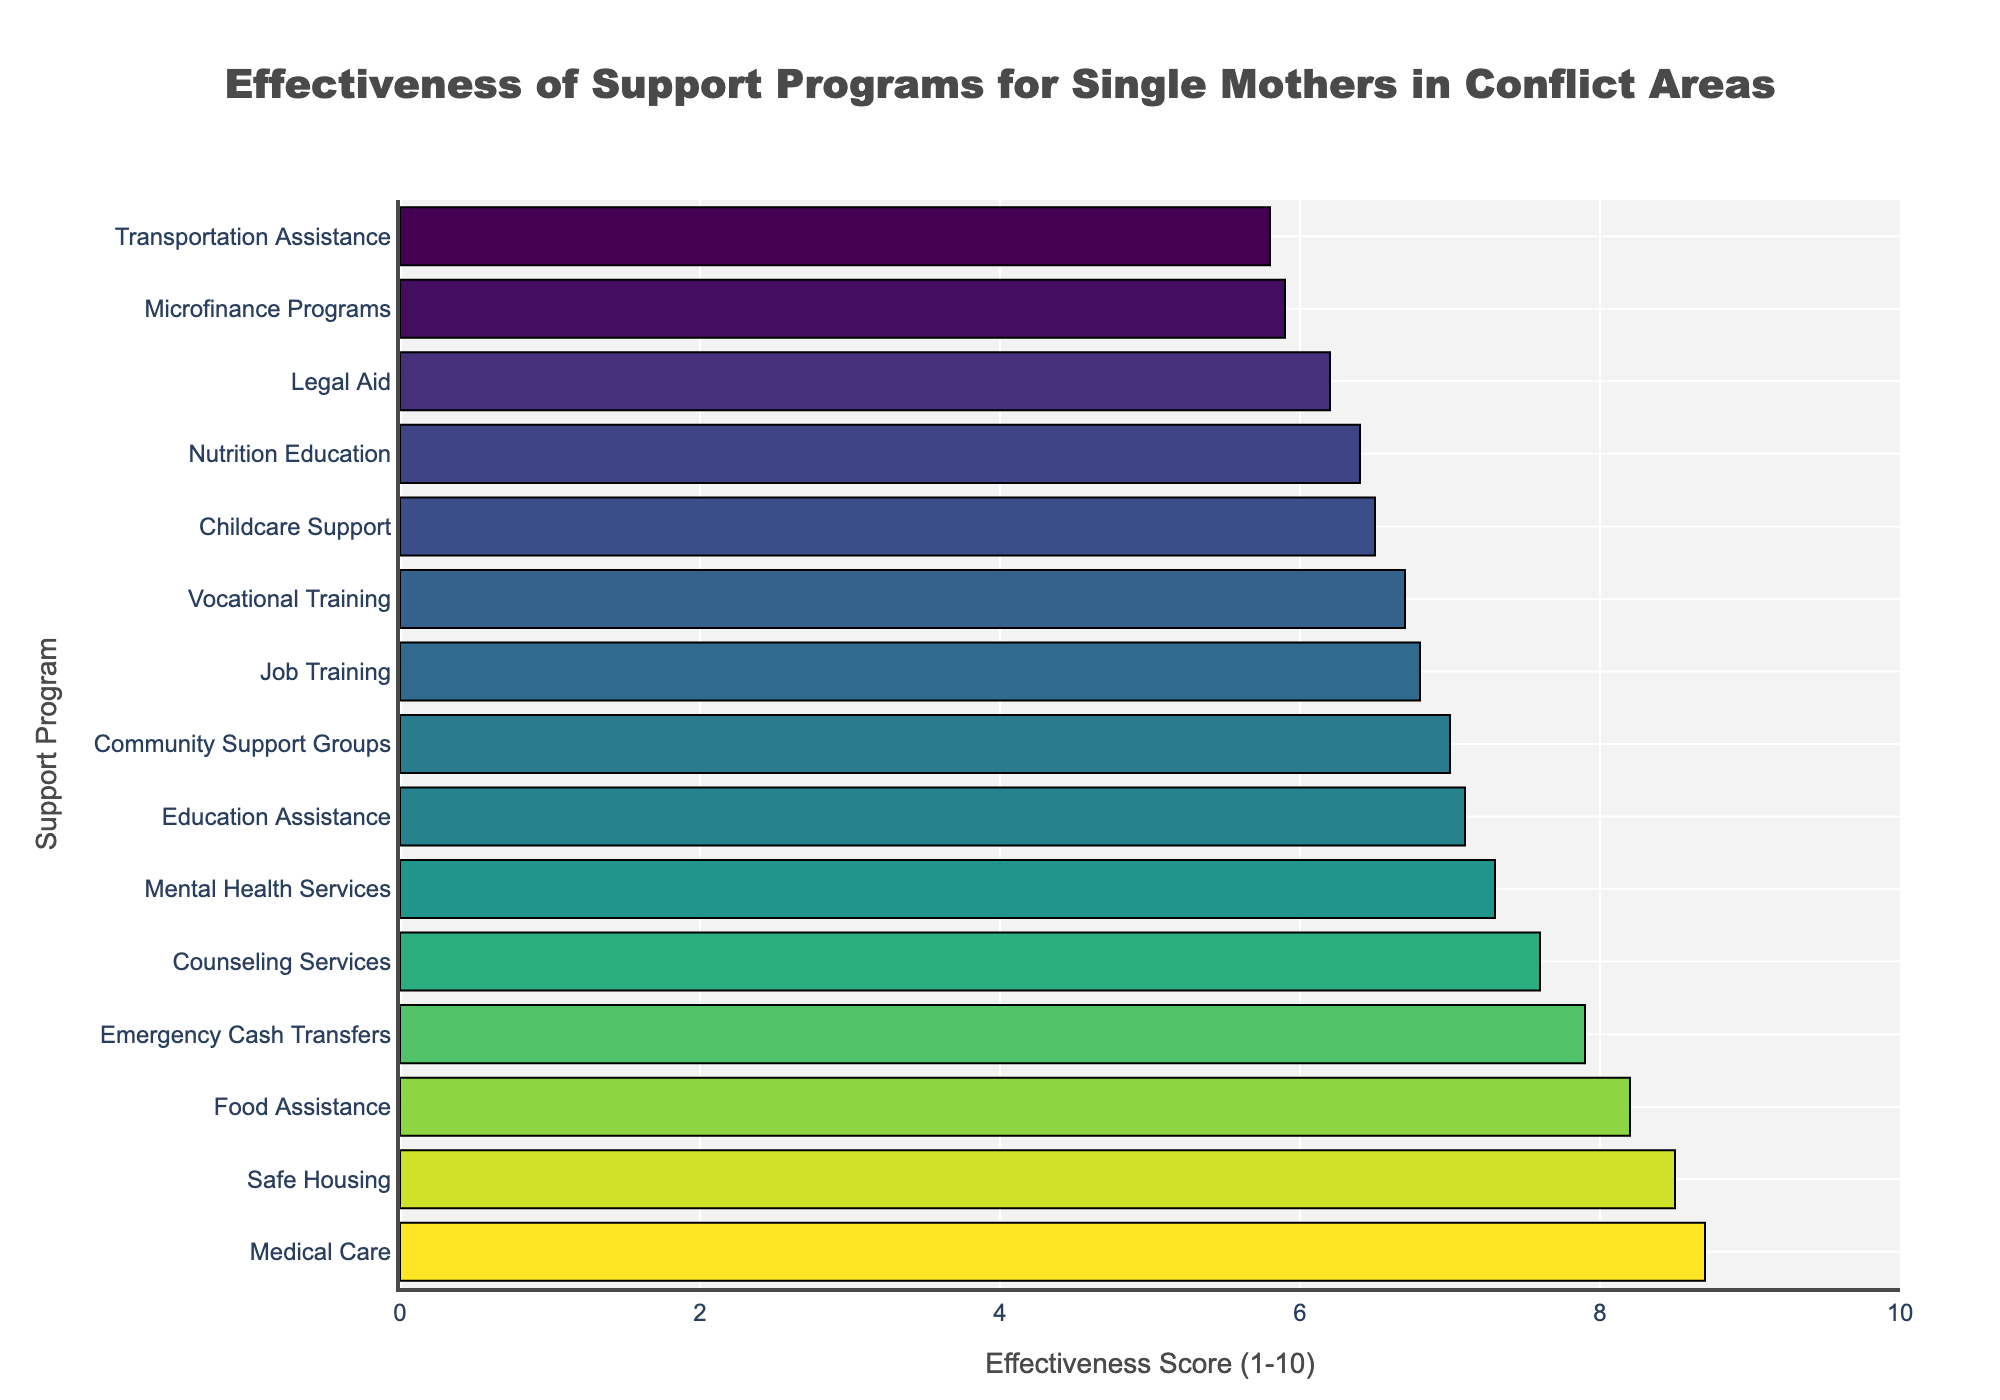Which program is rated as the most effective? The program with the highest effectiveness score is identified by looking at the top bar in the chart.
Answer: Medical Care Which program is rated as the least effective? The program with the lowest effectiveness score is identified by looking at the bottom bar in the chart.
Answer: Transportation Assistance What is the effectiveness score gap between Safe Housing and Job Training? Safe Housing has an effectiveness score of 8.5, and Job Training has a score of 6.8. The gap is 8.5 - 6.8.
Answer: 1.7 How many programs have an effectiveness score greater than 7.0? Count all the bars with an effectiveness score above 7.0.
Answer: 7 programs What is the average effectiveness score of Food Assistance, Emergency Cash Transfers, and Mental Health Services? Sum the effectiveness scores: 8.2 (Food Assistance) + 7.9 (Emergency Cash Transfers) + 7.3 (Mental Health Services) = 23.4. Divide by 3 to get the average.
Answer: 7.8 Which program is more effective: Education Assistance or Job Training? Compare the effectiveness scores. Education Assistance has 7.1, and Job Training has 6.8.
Answer: Education Assistance What is the effectiveness score range of Nutrition Education, Community Support Groups, and Legal Aid? Find the highest and lowest scores among them: 7.0 (Community Support Groups) - 6.2 (Legal Aid).
Answer: 0.8 Which programs have an effectiveness score within 6 to 7? Identify all programs with scores between 6.0 and 7.0. These are: Childcare Support (6.5), Job Training (6.8), Legal Aid (6.2), Vocational Training (6.7), Nutrition Education (6.4), Community Support Groups (7.0).
Answer: 6 programs What is the median effectiveness score of all programs? List all scores, sort them, and find the middle value. Scores (from highest to lowest): [8.7, 8.5, 8.2, 7.9, 7.6, 7.3, 7.1, 7.0, 6.8, 6.7, 6.5, 6.4, 6.2, 5.9, 5.8]. Median (8th value when sorted) is 7.1.
Answer: 7.1 What is the total effectiveness score for all programs combined? Sum the effectiveness scores of all programs: 8.2 + 7.9 + 6.5 + 6.8 + 7.3 + 7.1 + 8.5 + 8.7 + 6.2 + 5.9 + 7.6 + 6.7 + 6.4 + 7.0 + 5.8.
Answer: 100.6 